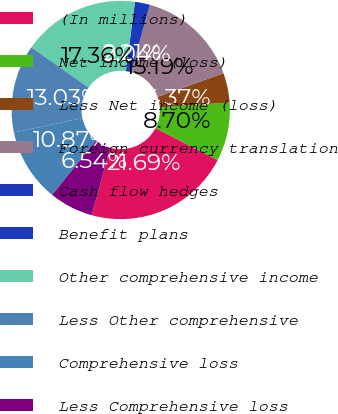Convert chart to OTSL. <chart><loc_0><loc_0><loc_500><loc_500><pie_chart><fcel>(In millions)<fcel>Net income (loss)<fcel>Less Net income (loss)<fcel>Foreign currency translation<fcel>Cash flow hedges<fcel>Benefit plans<fcel>Other comprehensive income<fcel>Less Other comprehensive<fcel>Comprehensive loss<fcel>Less Comprehensive loss<nl><fcel>21.69%<fcel>8.7%<fcel>4.37%<fcel>15.19%<fcel>0.04%<fcel>2.21%<fcel>17.36%<fcel>13.03%<fcel>10.87%<fcel>6.54%<nl></chart> 